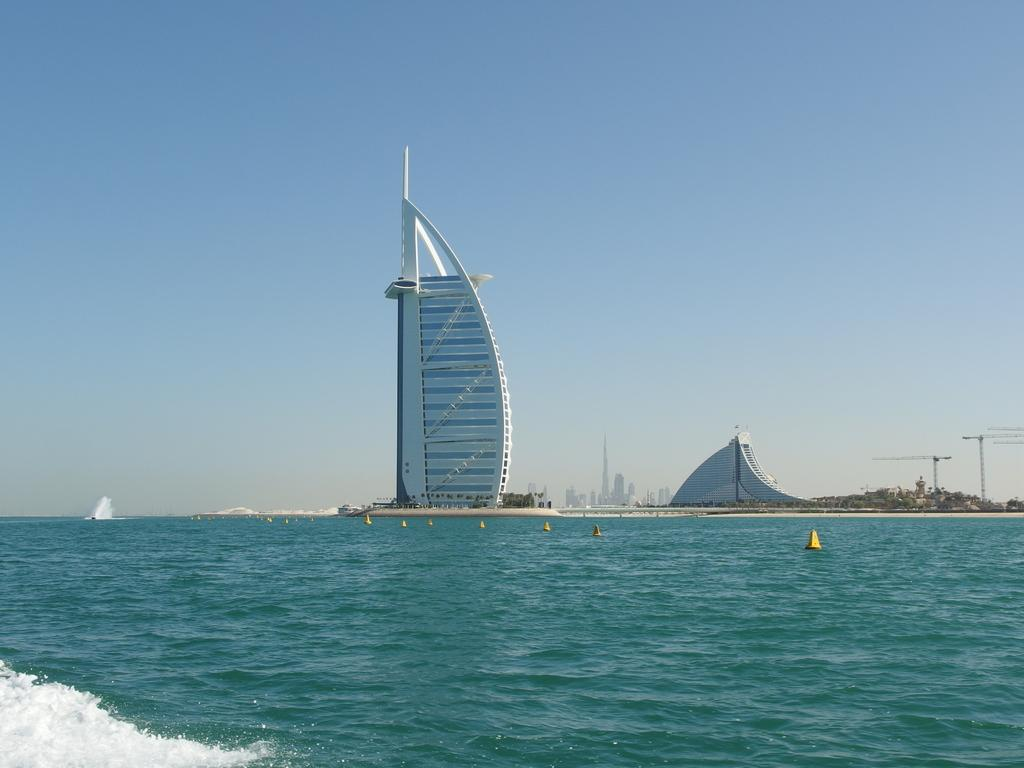What is located in the center of the image? There are buildings and poles in the center of the image. What can be seen at the bottom of the image? There is water at the bottom of the image. What is visible in the background of the image? The sky is visible in the background of the image. What type of country is depicted in the image? There is no country depicted in the image; it features buildings, poles, water, and sky. Can you tell me how many ploughs are visible in the image? There are no ploughs present in the image. 